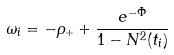<formula> <loc_0><loc_0><loc_500><loc_500>\omega _ { i } = - \rho _ { + } + \frac { e ^ { - \bar { \Phi } } } { 1 - N ^ { 2 } ( t _ { i } ) }</formula> 